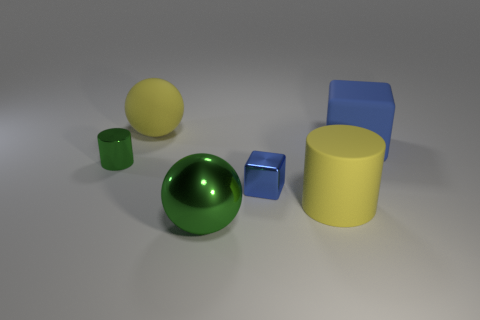Do the big matte thing to the left of the big green metallic ball and the small thing that is left of the small blue cube have the same shape?
Your answer should be very brief. No. Are there an equal number of blue matte cubes behind the big matte ball and large gray rubber things?
Ensure brevity in your answer.  Yes. What color is the other object that is the same shape as the large blue matte thing?
Your answer should be very brief. Blue. Are the block that is behind the small green object and the tiny blue thing made of the same material?
Give a very brief answer. No. What number of large objects are green cylinders or rubber things?
Provide a succinct answer. 3. The green sphere is what size?
Keep it short and to the point. Large. There is a rubber cube; is its size the same as the yellow rubber thing in front of the green cylinder?
Your answer should be compact. Yes. How many blue objects are large rubber blocks or big cylinders?
Provide a succinct answer. 1. How many blue rubber things are there?
Your answer should be compact. 1. What size is the metallic thing that is on the left side of the big metallic sphere?
Offer a terse response. Small. 